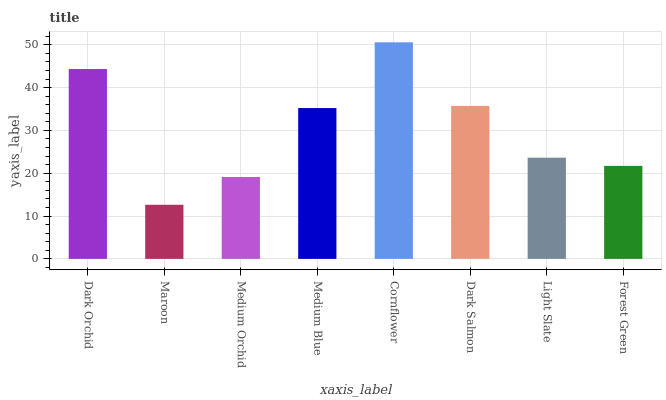Is Maroon the minimum?
Answer yes or no. Yes. Is Cornflower the maximum?
Answer yes or no. Yes. Is Medium Orchid the minimum?
Answer yes or no. No. Is Medium Orchid the maximum?
Answer yes or no. No. Is Medium Orchid greater than Maroon?
Answer yes or no. Yes. Is Maroon less than Medium Orchid?
Answer yes or no. Yes. Is Maroon greater than Medium Orchid?
Answer yes or no. No. Is Medium Orchid less than Maroon?
Answer yes or no. No. Is Medium Blue the high median?
Answer yes or no. Yes. Is Light Slate the low median?
Answer yes or no. Yes. Is Dark Orchid the high median?
Answer yes or no. No. Is Dark Salmon the low median?
Answer yes or no. No. 